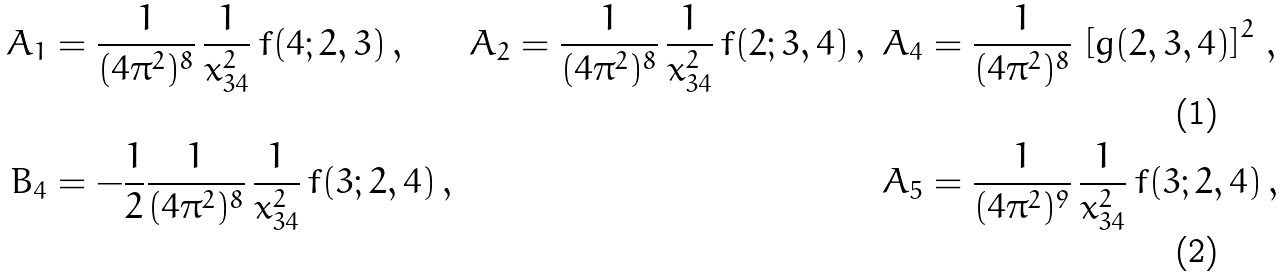<formula> <loc_0><loc_0><loc_500><loc_500>A _ { 1 } & = \frac { 1 } { ( 4 \pi ^ { 2 } ) ^ { 8 } } \, \frac { 1 } { x _ { 3 4 } ^ { 2 } } \, f ( 4 ; 2 , 3 ) \, , & A _ { 2 } & = \frac { 1 } { ( 4 \pi ^ { 2 } ) ^ { 8 } } \, \frac { 1 } { x _ { 3 4 } ^ { 2 } } \, f ( 2 ; 3 , 4 ) \, , & A _ { 4 } & = \frac { 1 } { ( 4 \pi ^ { 2 } ) ^ { 8 } } \, \left [ g ( 2 , 3 , 4 ) \right ] ^ { 2 } \, , \\ B _ { 4 } & = - \frac { 1 } { 2 } \frac { 1 } { ( 4 \pi ^ { 2 } ) ^ { 8 } } \, \frac { 1 } { x _ { 3 4 } ^ { 2 } } \, f ( 3 ; 2 , 4 ) \, , & & & A _ { 5 } & = \frac { 1 } { ( 4 \pi ^ { 2 } ) ^ { 9 } } \, \frac { 1 } { x _ { 3 4 } ^ { 2 } } \, f ( 3 ; 2 , 4 ) \, ,</formula> 